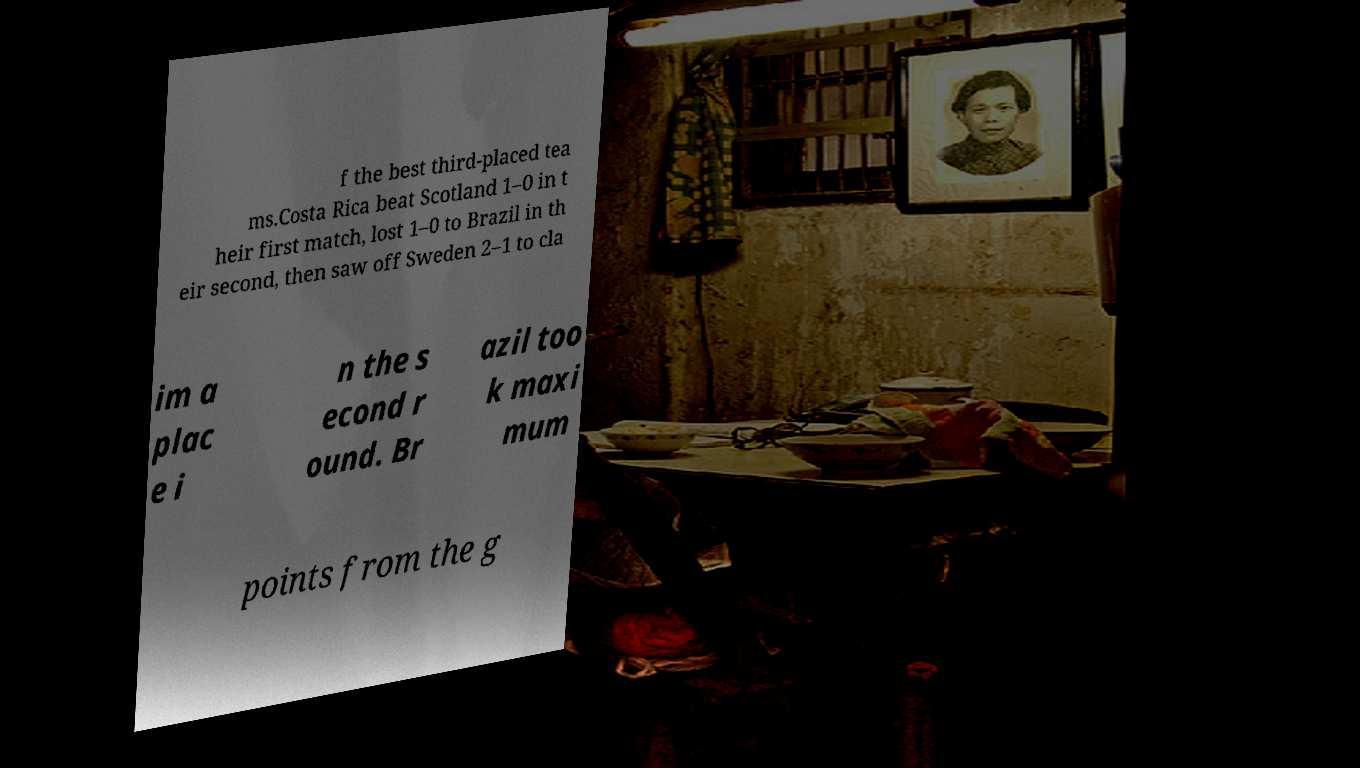Can you read and provide the text displayed in the image?This photo seems to have some interesting text. Can you extract and type it out for me? f the best third-placed tea ms.Costa Rica beat Scotland 1–0 in t heir first match, lost 1–0 to Brazil in th eir second, then saw off Sweden 2–1 to cla im a plac e i n the s econd r ound. Br azil too k maxi mum points from the g 